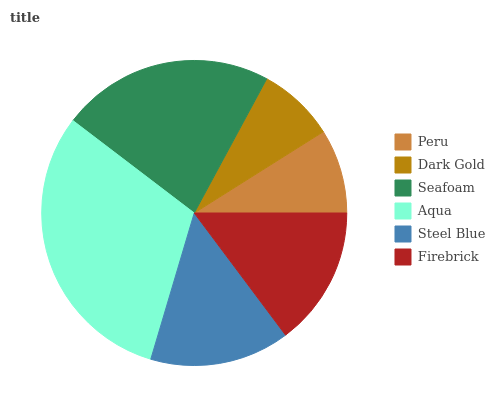Is Dark Gold the minimum?
Answer yes or no. Yes. Is Aqua the maximum?
Answer yes or no. Yes. Is Seafoam the minimum?
Answer yes or no. No. Is Seafoam the maximum?
Answer yes or no. No. Is Seafoam greater than Dark Gold?
Answer yes or no. Yes. Is Dark Gold less than Seafoam?
Answer yes or no. Yes. Is Dark Gold greater than Seafoam?
Answer yes or no. No. Is Seafoam less than Dark Gold?
Answer yes or no. No. Is Steel Blue the high median?
Answer yes or no. Yes. Is Firebrick the low median?
Answer yes or no. Yes. Is Seafoam the high median?
Answer yes or no. No. Is Aqua the low median?
Answer yes or no. No. 